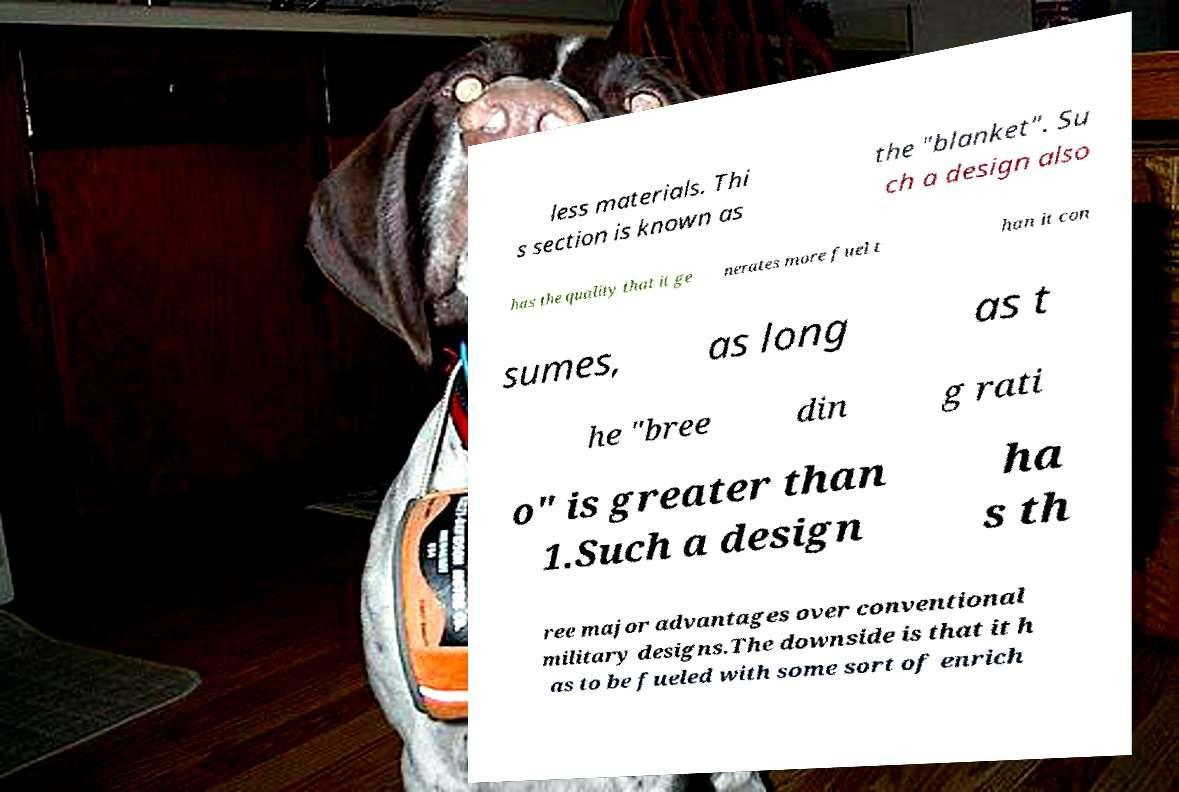For documentation purposes, I need the text within this image transcribed. Could you provide that? less materials. Thi s section is known as the "blanket". Su ch a design also has the quality that it ge nerates more fuel t han it con sumes, as long as t he "bree din g rati o" is greater than 1.Such a design ha s th ree major advantages over conventional military designs.The downside is that it h as to be fueled with some sort of enrich 